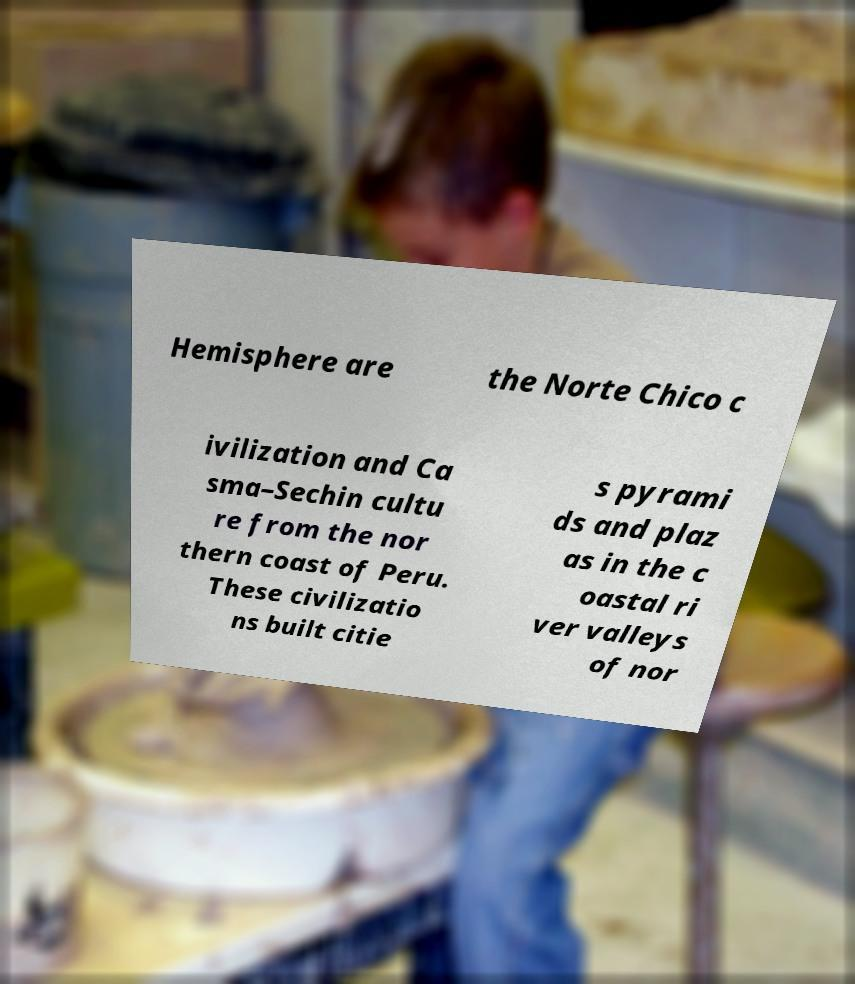Can you read and provide the text displayed in the image?This photo seems to have some interesting text. Can you extract and type it out for me? Hemisphere are the Norte Chico c ivilization and Ca sma–Sechin cultu re from the nor thern coast of Peru. These civilizatio ns built citie s pyrami ds and plaz as in the c oastal ri ver valleys of nor 